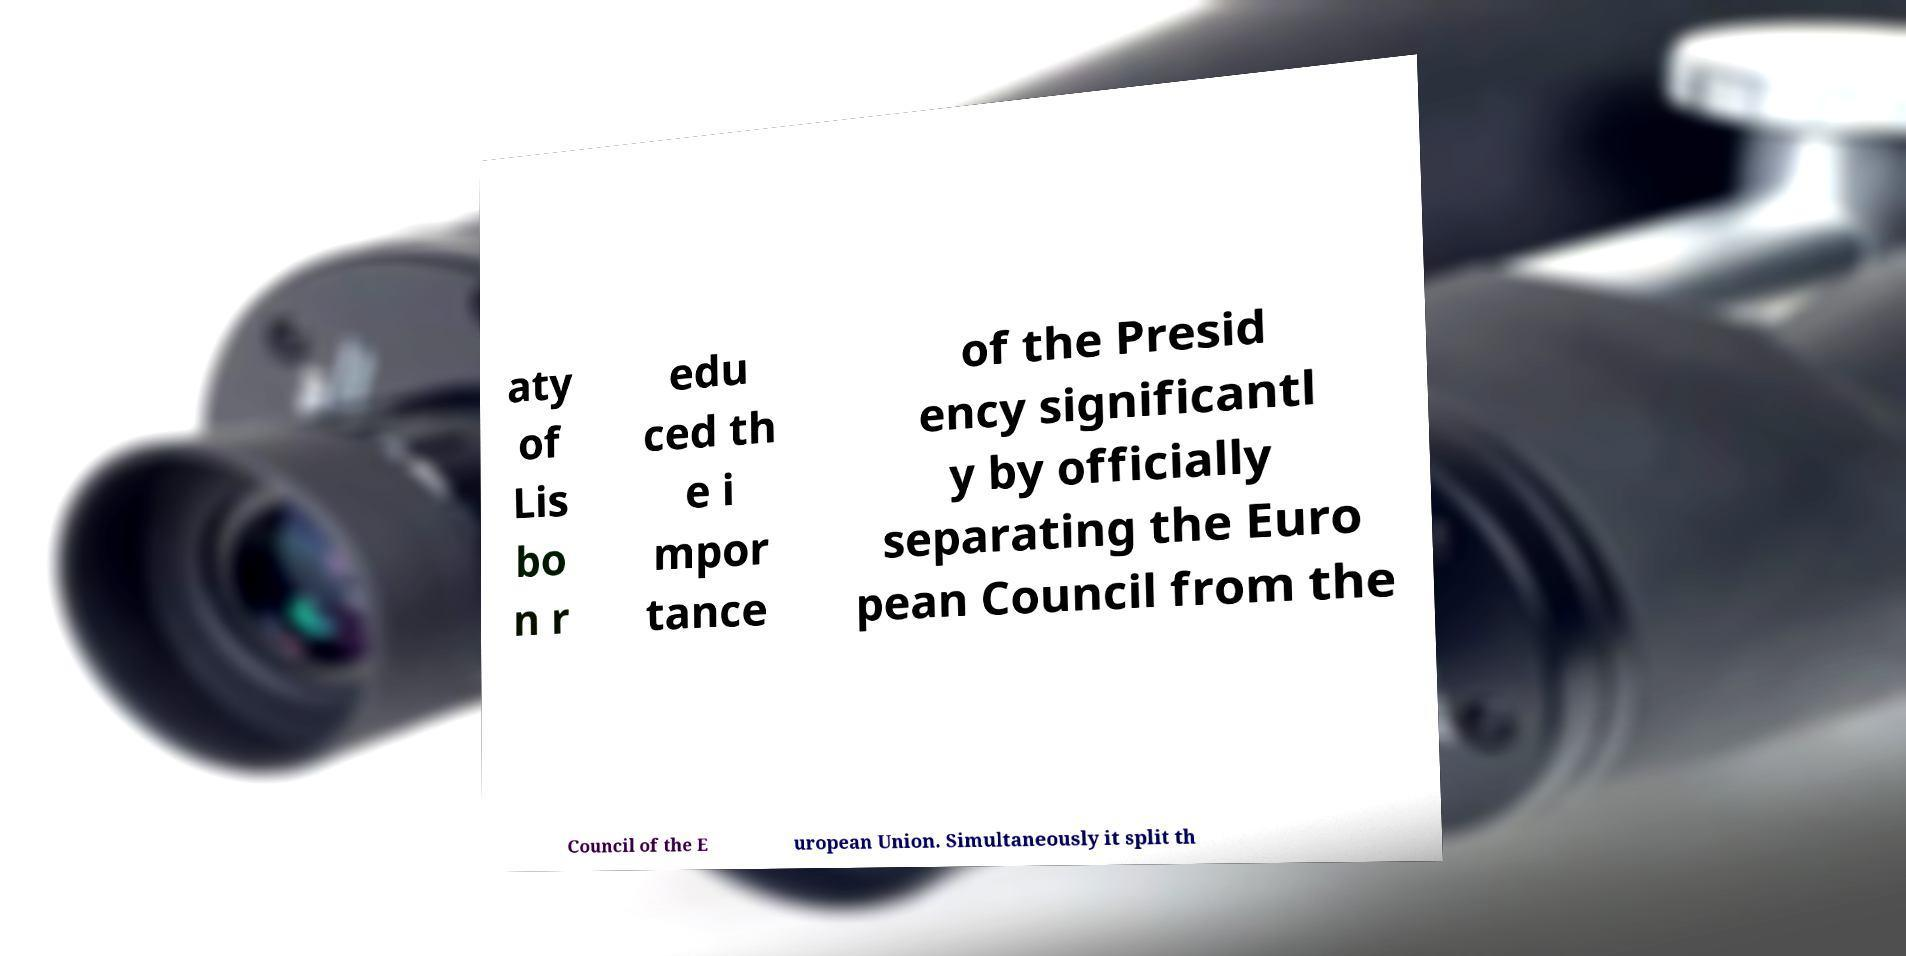Please identify and transcribe the text found in this image. aty of Lis bo n r edu ced th e i mpor tance of the Presid ency significantl y by officially separating the Euro pean Council from the Council of the E uropean Union. Simultaneously it split th 